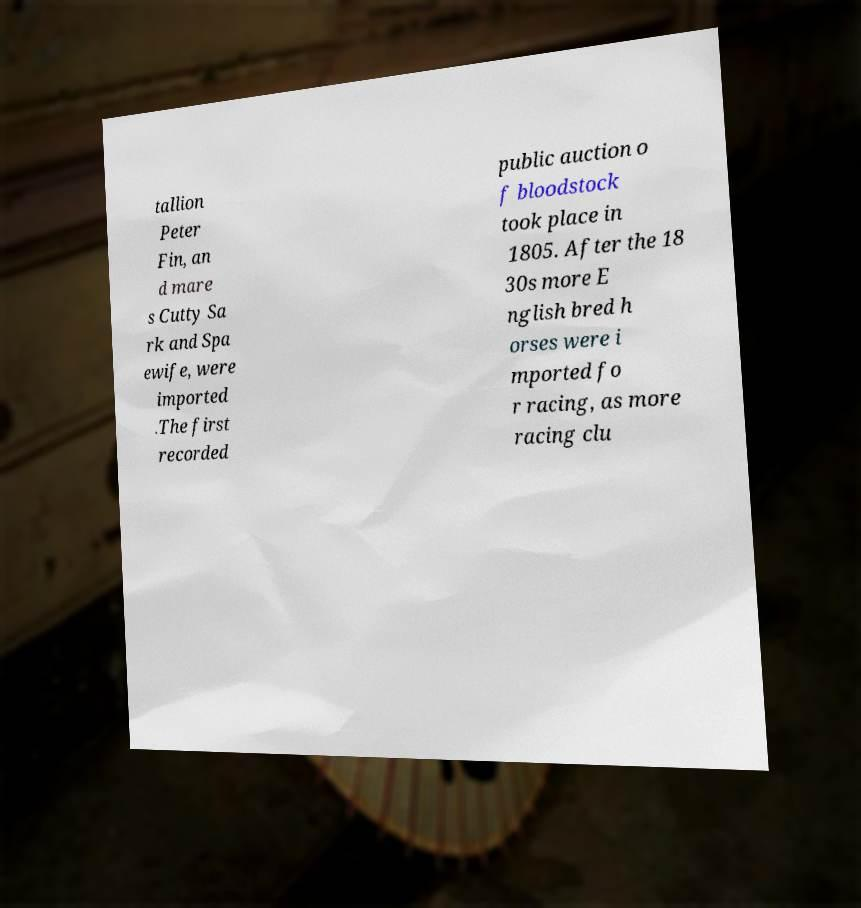Please read and relay the text visible in this image. What does it say? tallion Peter Fin, an d mare s Cutty Sa rk and Spa ewife, were imported .The first recorded public auction o f bloodstock took place in 1805. After the 18 30s more E nglish bred h orses were i mported fo r racing, as more racing clu 